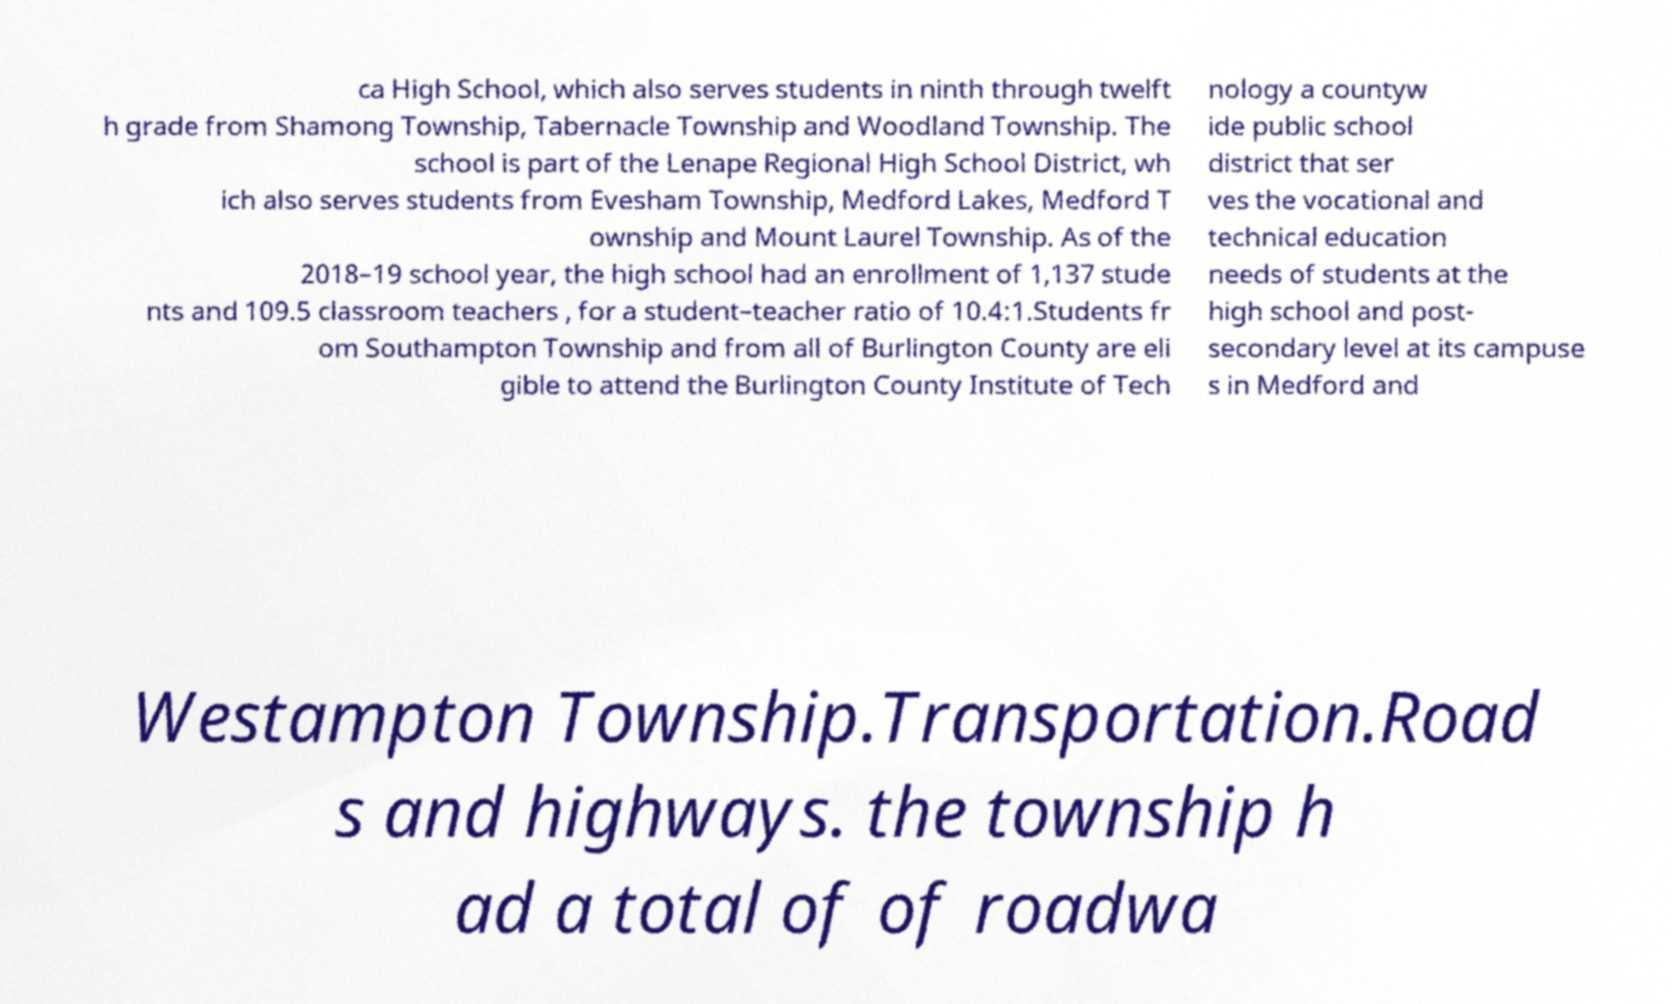What messages or text are displayed in this image? I need them in a readable, typed format. ca High School, which also serves students in ninth through twelft h grade from Shamong Township, Tabernacle Township and Woodland Township. The school is part of the Lenape Regional High School District, wh ich also serves students from Evesham Township, Medford Lakes, Medford T ownship and Mount Laurel Township. As of the 2018–19 school year, the high school had an enrollment of 1,137 stude nts and 109.5 classroom teachers , for a student–teacher ratio of 10.4:1.Students fr om Southampton Township and from all of Burlington County are eli gible to attend the Burlington County Institute of Tech nology a countyw ide public school district that ser ves the vocational and technical education needs of students at the high school and post- secondary level at its campuse s in Medford and Westampton Township.Transportation.Road s and highways. the township h ad a total of of roadwa 